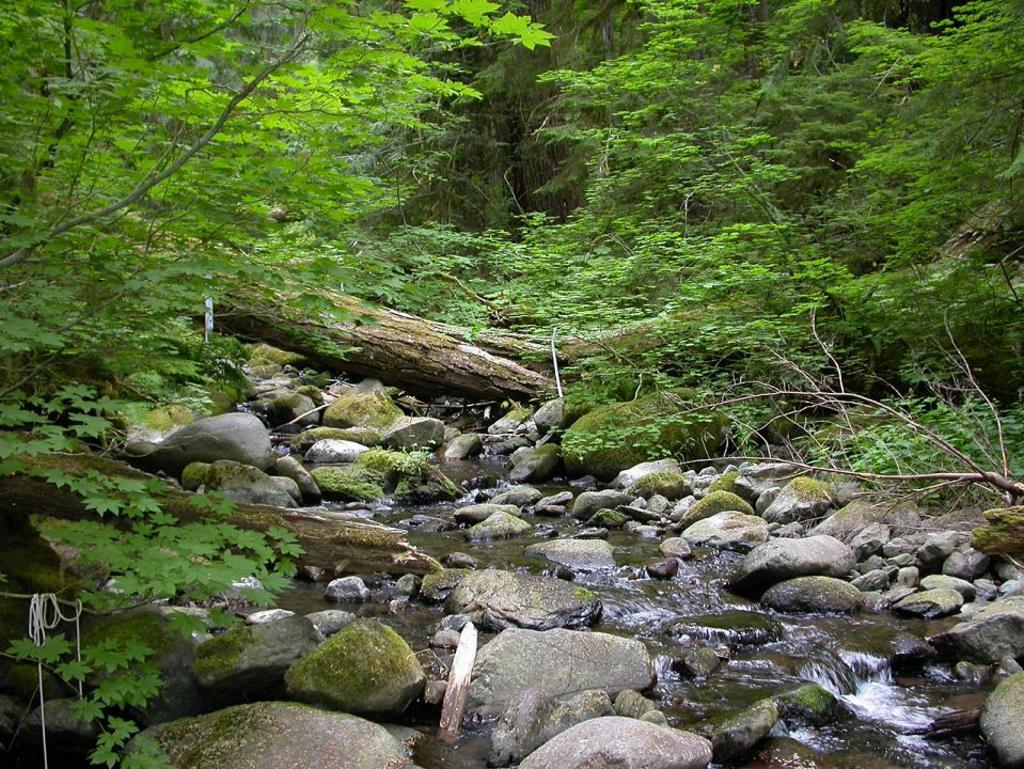What is the main feature in the middle of the image? There is a water flow in the middle of the image. What can be seen in the background of the image? There are many trees in the background of the image. Can you describe the tree trunk in the middle of the image? Yes, there is a tree trunk in the middle of the image. What is present at the bottom of the image? There are stones at the bottom of the image. What type of underwear is hanging on the tree in the image? There is no underwear present in the image; it only features a water flow, trees, a tree trunk, and stones. 